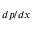Convert formula to latex. <formula><loc_0><loc_0><loc_500><loc_500>d p / d x</formula> 